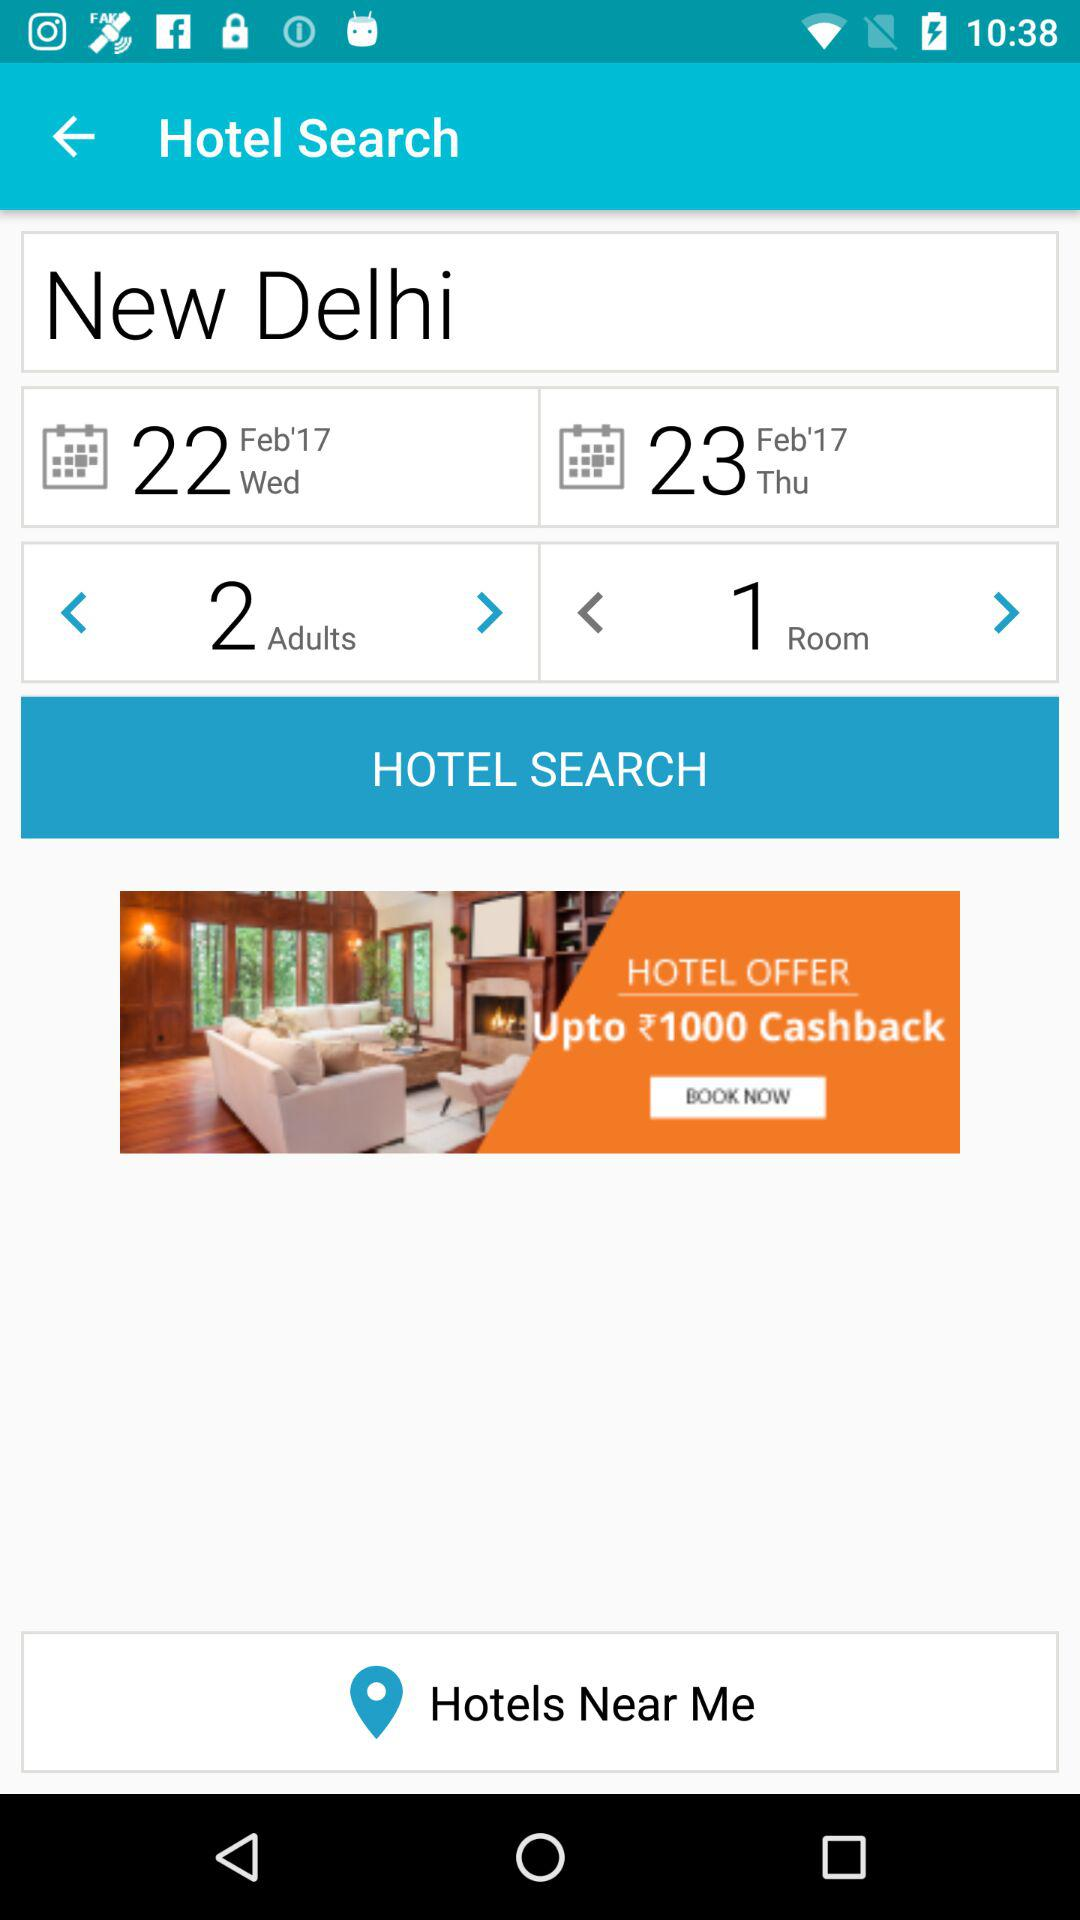What is the location? The location is New Delhi. 